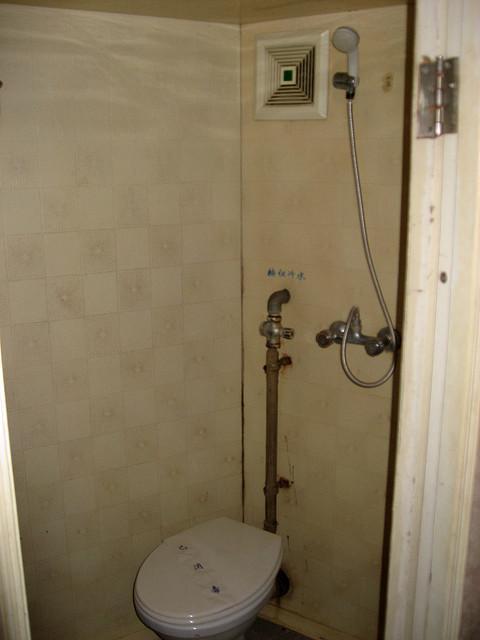How many zebras are shown?
Give a very brief answer. 0. 